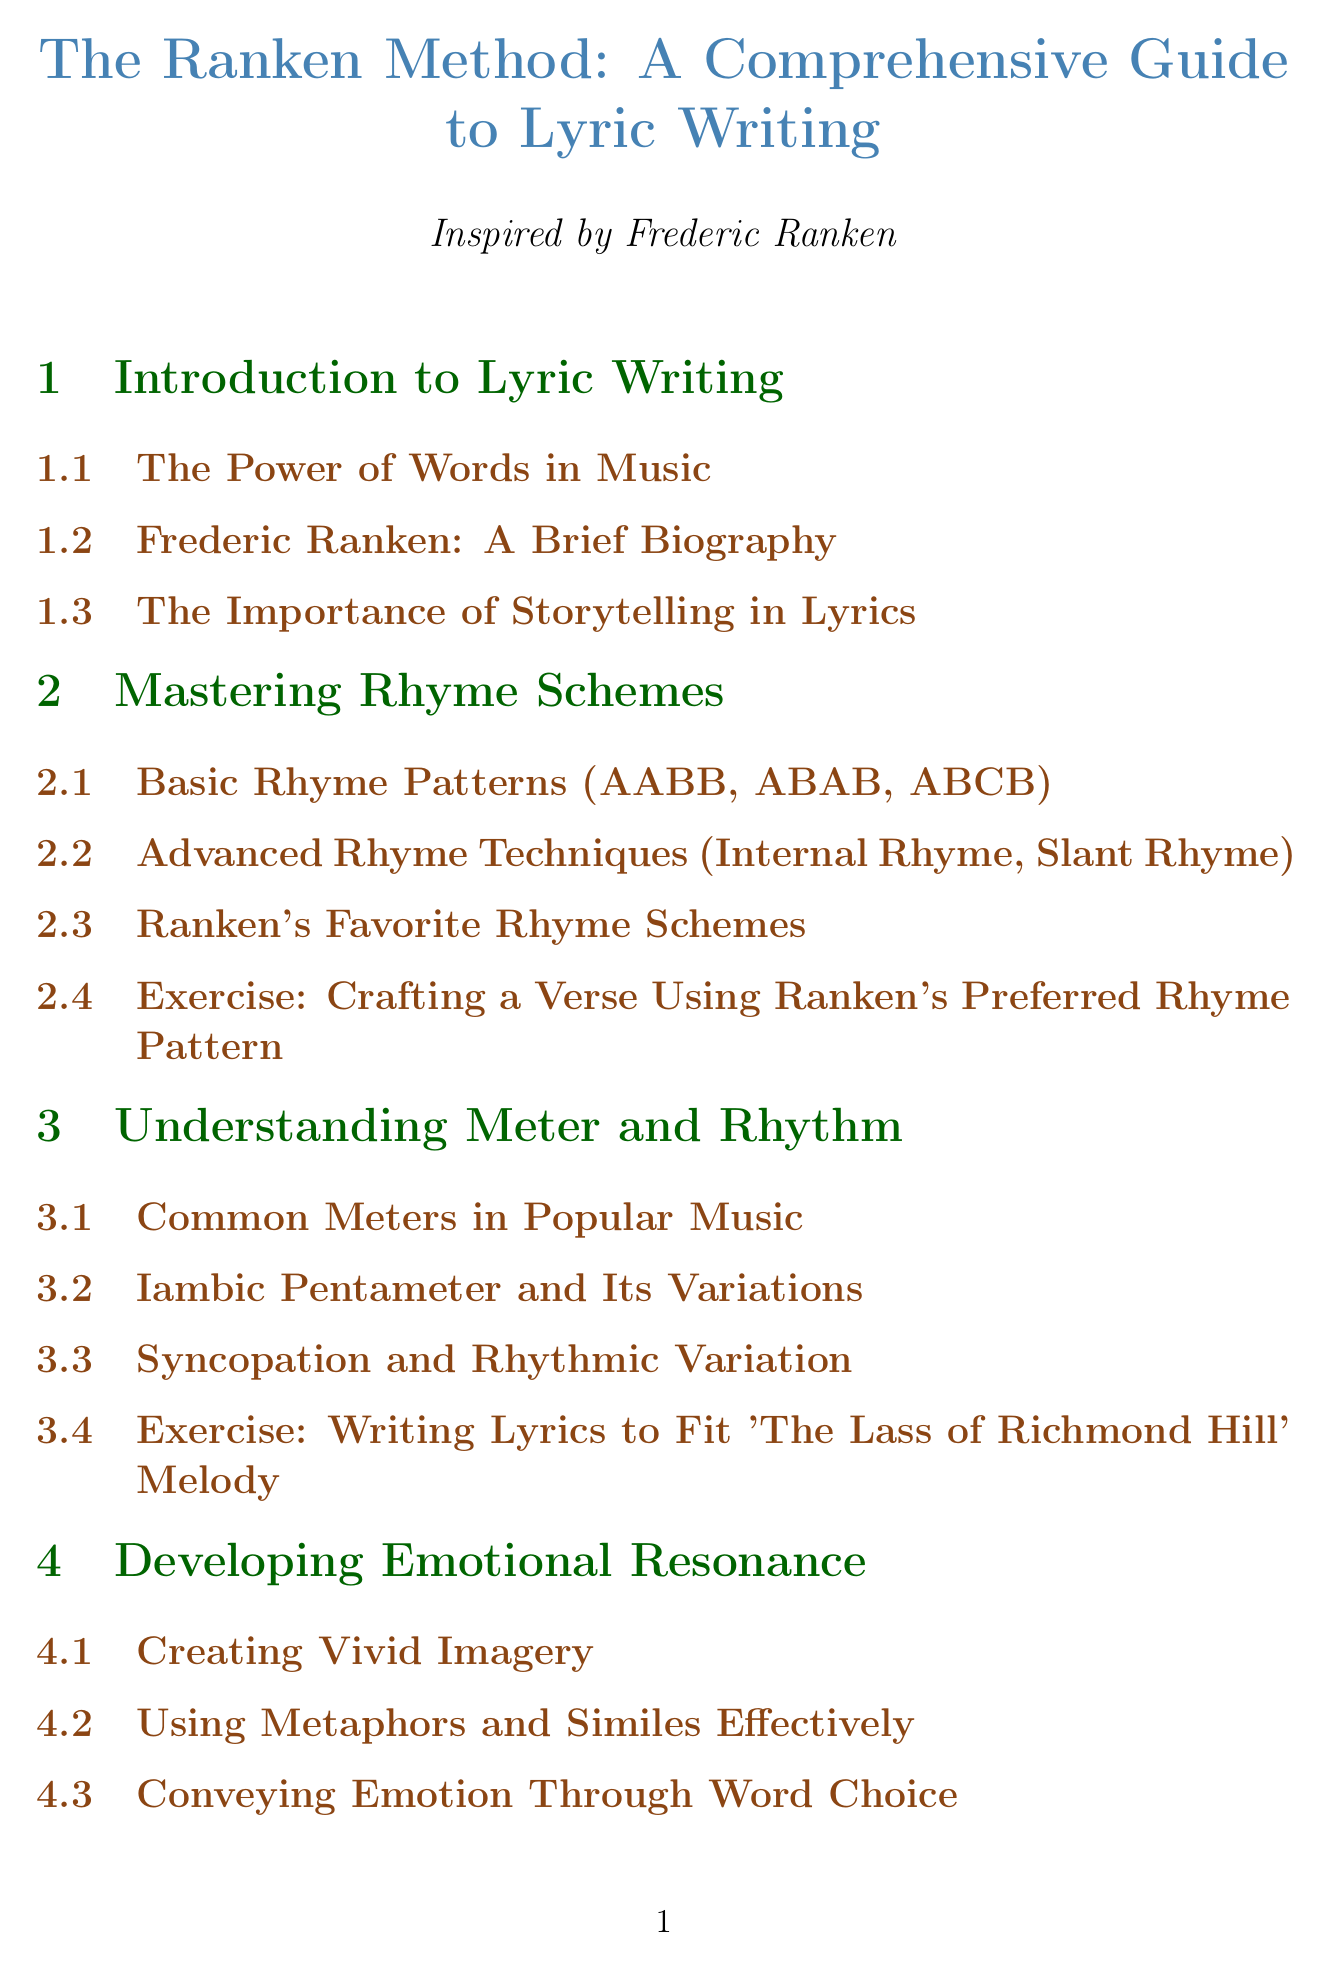What is the title of the manual? The title of the manual is explicitly stated at the beginning of the document.
Answer: The Ranken Method: A Comprehensive Guide to Lyric Writing How many chapters are there in the document? The number of chapters can be counted from the structure of the document.
Answer: Eight What is an example of an exercise included in the manual? The manual includes specific exercises designed to practice lyric writing techniques.
Answer: Crafting a Verse Using Ranken's Preferred Rhyme Pattern Which section covers emotional resonance? The section related to emotional resonance is dedicated to techniques for conveying feelings in lyrics.
Answer: Developing Emotional Resonance Who is the manual inspired by? The manual attributes its inspiration to a notable figure in lyric writing.
Answer: Frederic Ranken What type of structure does the manual include for song writing? The manual describes various structures that can be used in lyric writing, addressing different formats.
Answer: Verse-Chorus-Bridge Format Which appendix contains a glossary of lyrical terms? The appendix providing definitions of technical terms in lyric writing is clearly listed in the document.
Answer: Appendix A: Glossary of Lyrical Terms What is the focus of the first case study? The first case study gives an analysis of a specific well-known work by Frederic Ranken.
Answer: When You and I Were Young, Maggie 